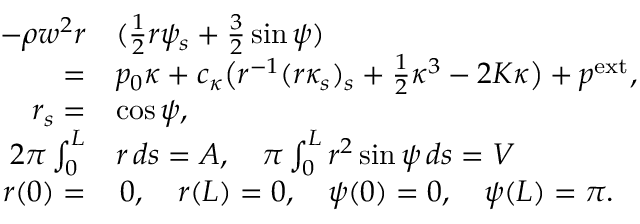Convert formula to latex. <formula><loc_0><loc_0><loc_500><loc_500>\begin{array} { r l } { - \rho w ^ { 2 } r } & { ( \frac { 1 } 2 r \psi _ { s } + \frac { 3 } { 2 } \sin \psi ) } \\ { = } & { p _ { 0 } \kappa + c _ { \kappa } \left ( r ^ { - 1 } ( r \kappa _ { s } ) _ { s } + \frac { 1 } { 2 } \kappa ^ { 3 } - 2 K \kappa \right ) + p ^ { e x t } , } \\ { r _ { s } = } & { \cos \psi , } \\ { 2 \pi \int _ { 0 } ^ { L } } & { r \, d s = A , \quad \pi \int _ { 0 } ^ { L } r ^ { 2 } \sin \psi \, d s = V } \\ { r ( 0 ) = } & { \, 0 , \quad r ( L ) = 0 , \quad \psi ( 0 ) = 0 , \quad \psi ( L ) = \pi . } \end{array}</formula> 